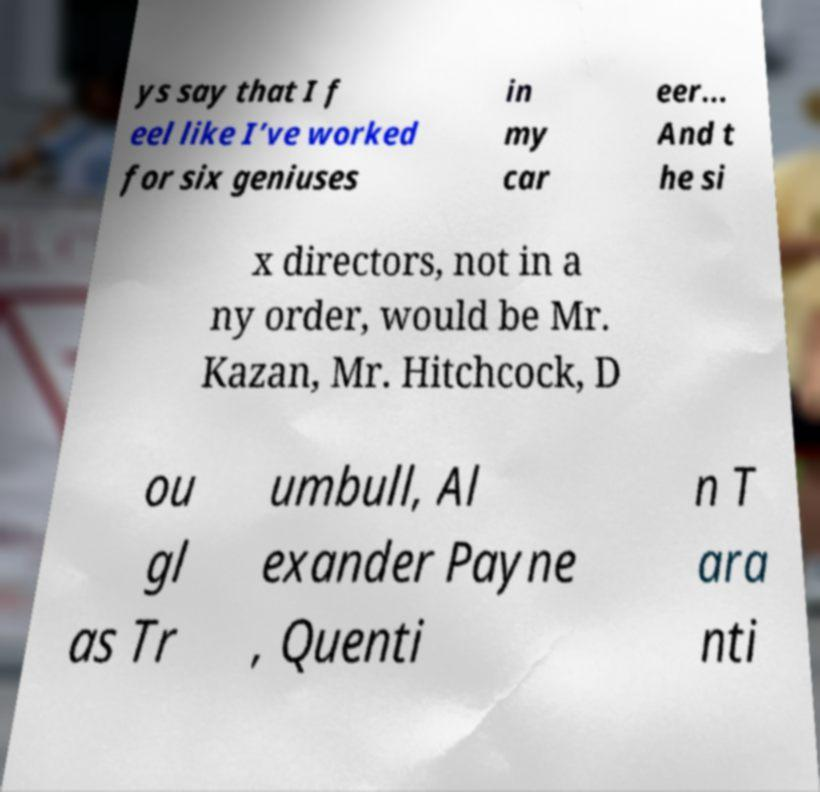I need the written content from this picture converted into text. Can you do that? ys say that I f eel like I’ve worked for six geniuses in my car eer... And t he si x directors, not in a ny order, would be Mr. Kazan, Mr. Hitchcock, D ou gl as Tr umbull, Al exander Payne , Quenti n T ara nti 